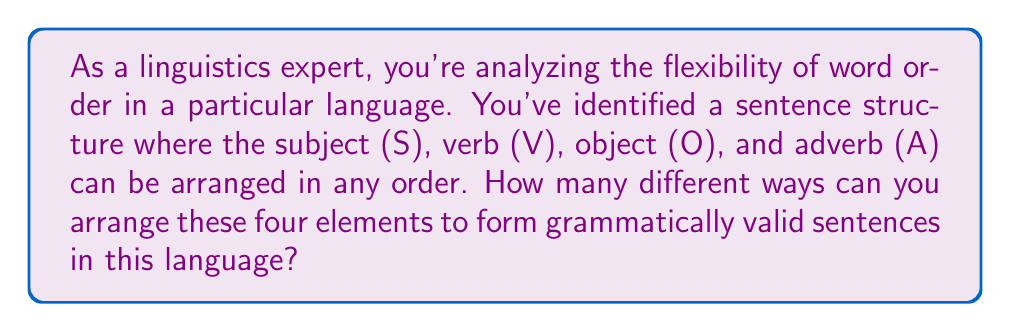Can you solve this math problem? To solve this problem, we need to use the concept of permutations. In this case, we have 4 distinct elements (S, V, O, and A) that can be arranged in any order. This is a perfect scenario for calculating permutations.

The formula for permutations of n distinct objects is:

$$P(n) = n!$$

Where $n!$ represents the factorial of n.

In our case, $n = 4$ (S, V, O, and A).

So, we calculate:

$$P(4) = 4!$$

To expand this:

$$4! = 4 \times 3 \times 2 \times 1 = 24$$

This means there are 24 possible arrangements of these four elements.

To illustrate, some of these arrangements could be:
SVOA, VSOA, ASVO, OASV, etc.

Each of these arrangements represents a possible sentence structure in the language you're analyzing, demonstrating the high degree of word order flexibility in this particular linguistic system.
Answer: $24$ different arrangements 